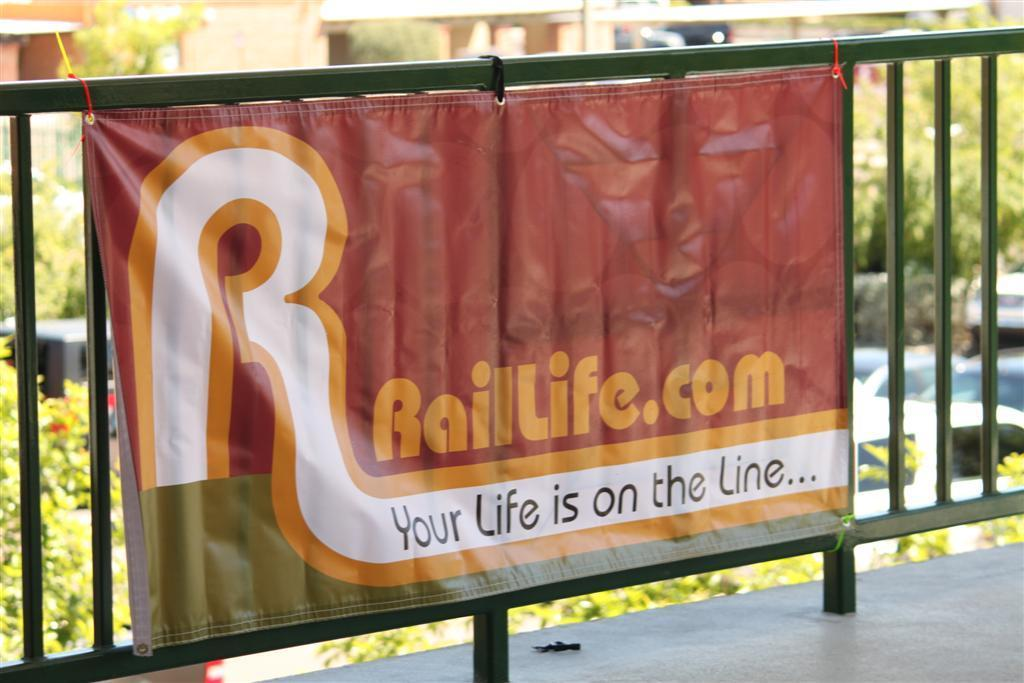<image>
Summarize the visual content of the image. A banner displays the Rail Life website and a slogan. 